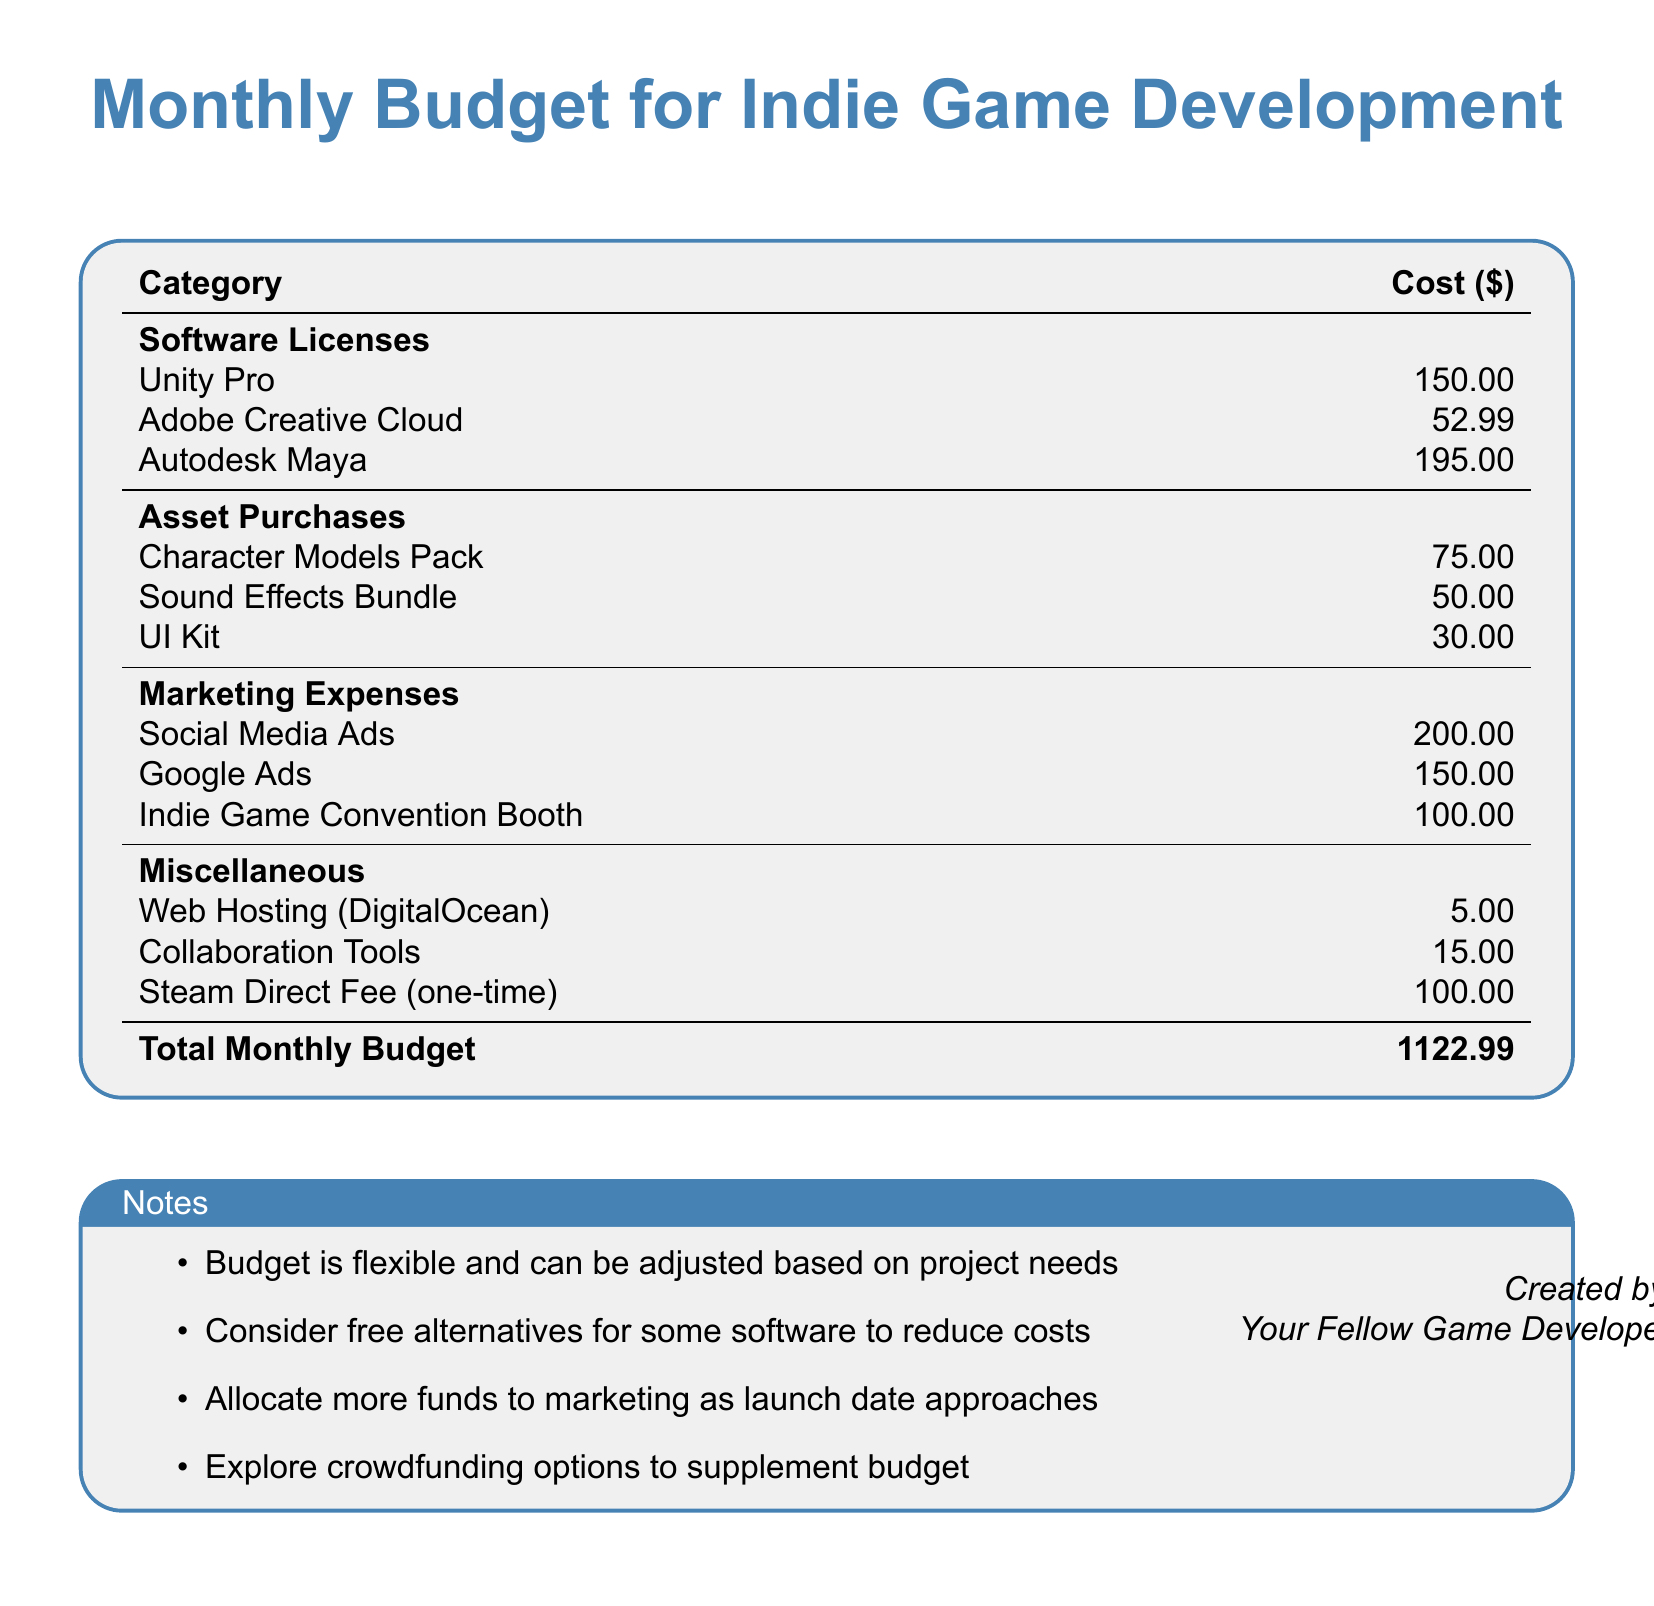What is the cost of Unity Pro? The document states the cost for Unity Pro under the Software Licenses category, which is $150.00.
Answer: $150.00 What are the total marketing expenses? The total marketing expenses can be calculated by adding all the individual marketing costs: $200.00 + $150.00 + $100.00 = $450.00.
Answer: $450.00 How much is spent on sound effects? The cost of the Sound Effects Bundle is listed in the Asset Purchases section, which is $50.00.
Answer: $50.00 What is the total monthly budget? The total monthly budget is clearly stated at the bottom of the budget document, which is $1122.99.
Answer: $1122.99 How much does web hosting cost? The document specifies that web hosting costs $5.00 under the Miscellaneous category.
Answer: $5.00 What percentage of the total budget is allocated for marketing? This requires calculating the marketing expenses ($450.00) as a percentage of the total budget ($1122.99), which is approximately 40%.
Answer: 40% What is one of the notes mentioned regarding the software licenses? One of the notes mentions considering free alternatives for some software to reduce costs.
Answer: Free alternatives What is the cost of the steam direct fee? The document lists the Steam Direct Fee under Miscellaneous, which is stated as $100.00.
Answer: $100.00 What does the budget suggest for funds allocation as the launch date approaches? The budget suggests allocating more funds to marketing as the launch date approaches.
Answer: More funds to marketing 